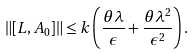Convert formula to latex. <formula><loc_0><loc_0><loc_500><loc_500>\| [ L , A _ { 0 } ] \| \leq k \left ( \frac { \theta \lambda } { \epsilon } + \frac { \theta \lambda ^ { 2 } } { \epsilon ^ { 2 } } \right ) .</formula> 